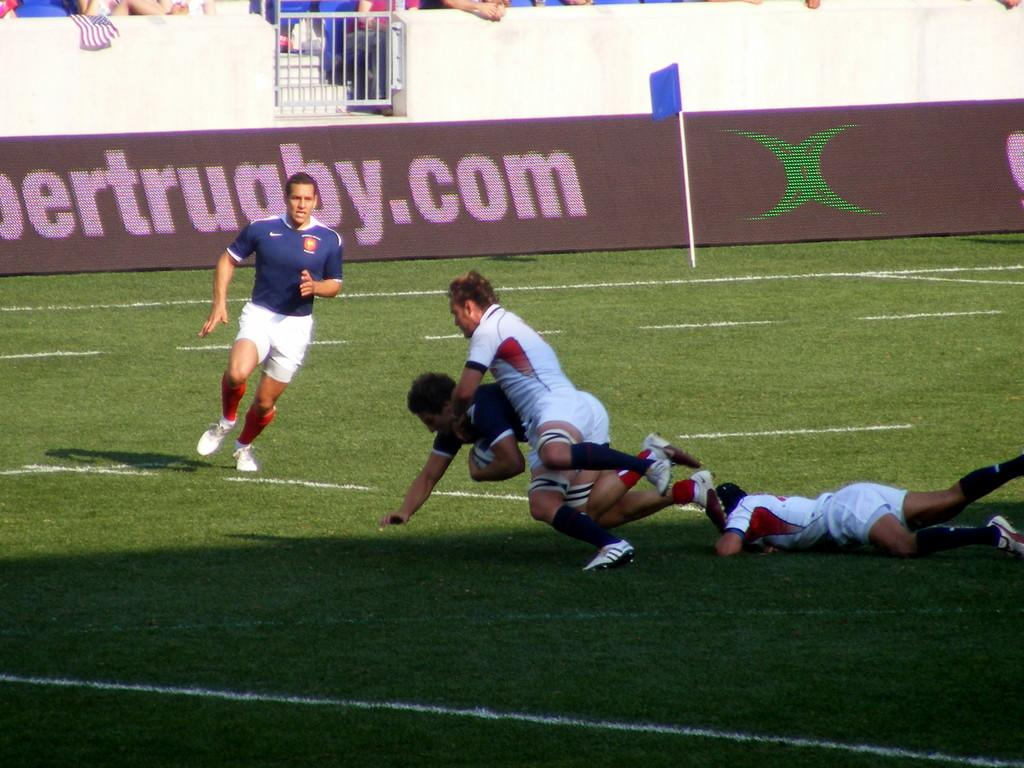What are the four men in the image doing? The four men in the image are running. What are they trying to do while running? They are trying to take a ball from another person. What can be seen in the background of the image? There is a gate, a wall, a flag, a pole, and other persons visible in the background of the image. What type of food is being served at the protest in the image? There is no protest or food present in the image; it features four men running to take a ball from another person. What is the profit margin for the company hosting the event in the image? There is no event or company mentioned in the image; it only shows four men running and a background with various objects and people. 